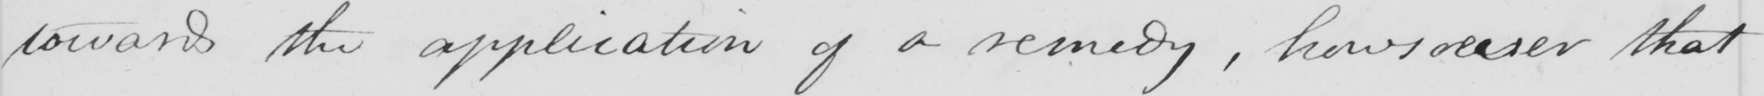Can you tell me what this handwritten text says? toward the application of a remedy , howsoever that 